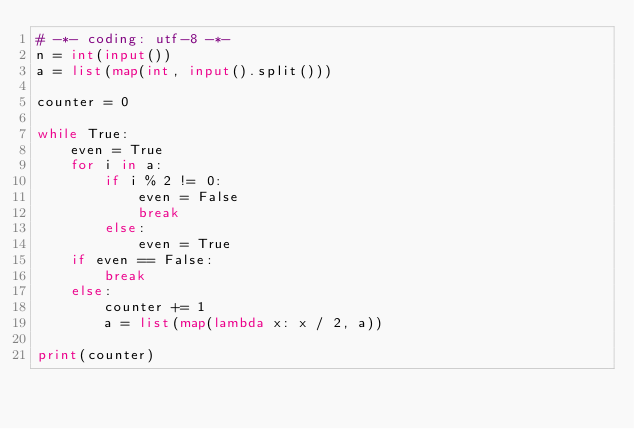Convert code to text. <code><loc_0><loc_0><loc_500><loc_500><_Python_># -*- coding: utf-8 -*-
n = int(input())
a = list(map(int, input().split()))

counter = 0

while True:
    even = True
    for i in a:
        if i % 2 != 0:
            even = False
            break
        else:
            even = True
    if even == False:
        break
    else:
        counter += 1
        a = list(map(lambda x: x / 2, a))

print(counter)</code> 